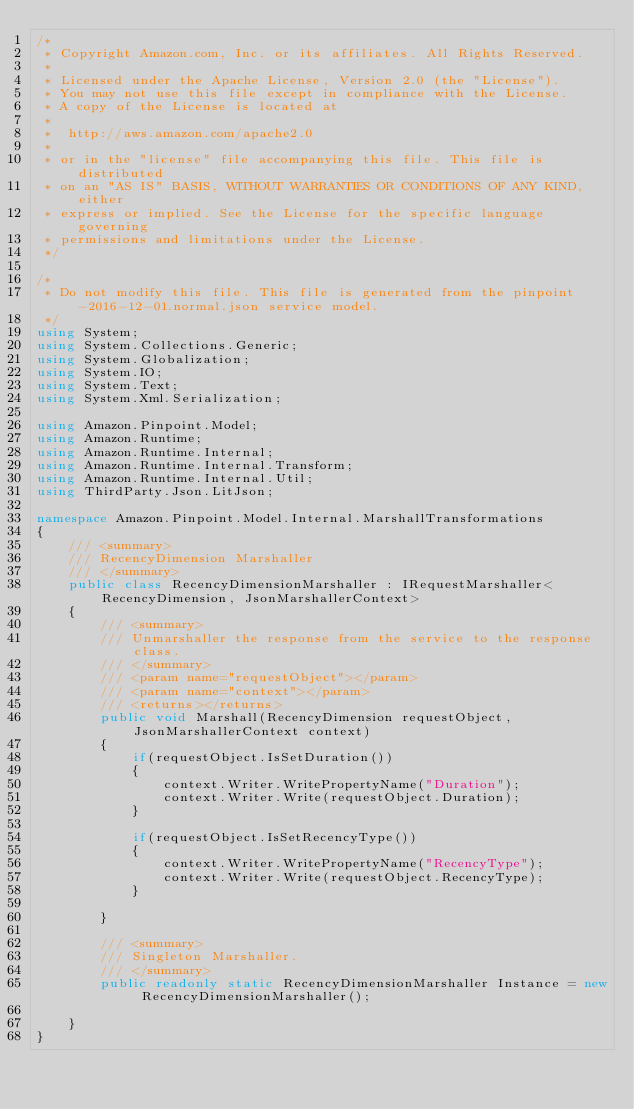Convert code to text. <code><loc_0><loc_0><loc_500><loc_500><_C#_>/*
 * Copyright Amazon.com, Inc. or its affiliates. All Rights Reserved.
 * 
 * Licensed under the Apache License, Version 2.0 (the "License").
 * You may not use this file except in compliance with the License.
 * A copy of the License is located at
 * 
 *  http://aws.amazon.com/apache2.0
 * 
 * or in the "license" file accompanying this file. This file is distributed
 * on an "AS IS" BASIS, WITHOUT WARRANTIES OR CONDITIONS OF ANY KIND, either
 * express or implied. See the License for the specific language governing
 * permissions and limitations under the License.
 */

/*
 * Do not modify this file. This file is generated from the pinpoint-2016-12-01.normal.json service model.
 */
using System;
using System.Collections.Generic;
using System.Globalization;
using System.IO;
using System.Text;
using System.Xml.Serialization;

using Amazon.Pinpoint.Model;
using Amazon.Runtime;
using Amazon.Runtime.Internal;
using Amazon.Runtime.Internal.Transform;
using Amazon.Runtime.Internal.Util;
using ThirdParty.Json.LitJson;

namespace Amazon.Pinpoint.Model.Internal.MarshallTransformations
{
    /// <summary>
    /// RecencyDimension Marshaller
    /// </summary>       
    public class RecencyDimensionMarshaller : IRequestMarshaller<RecencyDimension, JsonMarshallerContext> 
    {
        /// <summary>
        /// Unmarshaller the response from the service to the response class.
        /// </summary>  
        /// <param name="requestObject"></param>
        /// <param name="context"></param>
        /// <returns></returns>
        public void Marshall(RecencyDimension requestObject, JsonMarshallerContext context)
        {
            if(requestObject.IsSetDuration())
            {
                context.Writer.WritePropertyName("Duration");
                context.Writer.Write(requestObject.Duration);
            }

            if(requestObject.IsSetRecencyType())
            {
                context.Writer.WritePropertyName("RecencyType");
                context.Writer.Write(requestObject.RecencyType);
            }

        }

        /// <summary>
        /// Singleton Marshaller.
        /// </summary>  
        public readonly static RecencyDimensionMarshaller Instance = new RecencyDimensionMarshaller();

    }
}</code> 